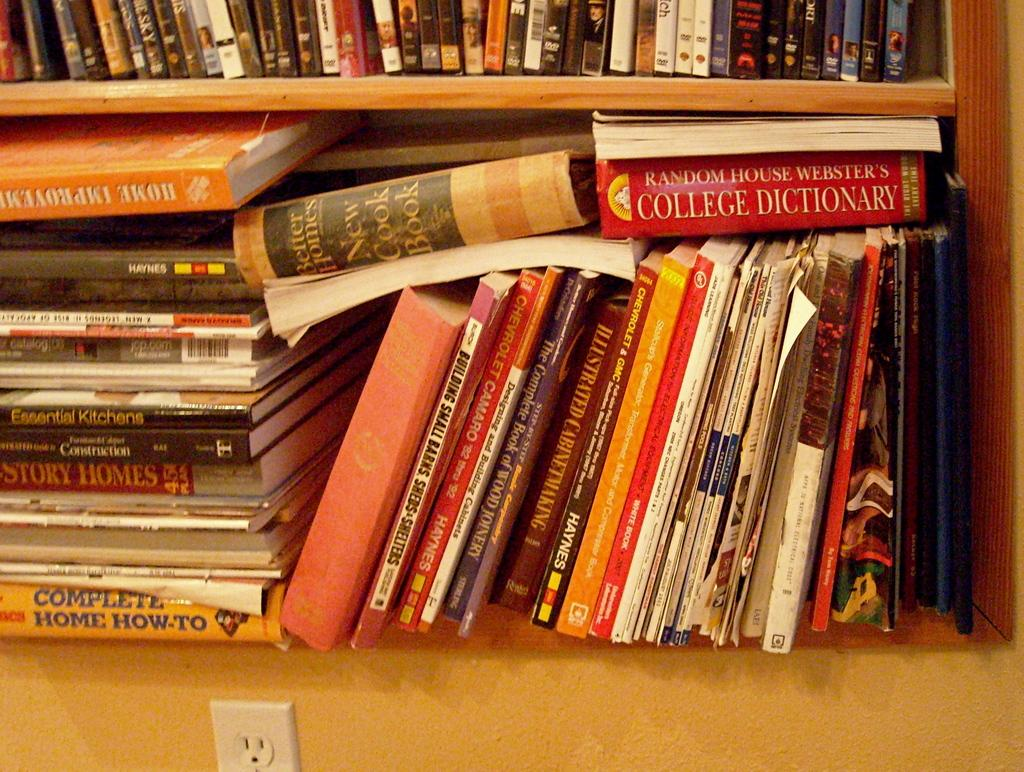<image>
Write a terse but informative summary of the picture. the words college dictionary are on a book 